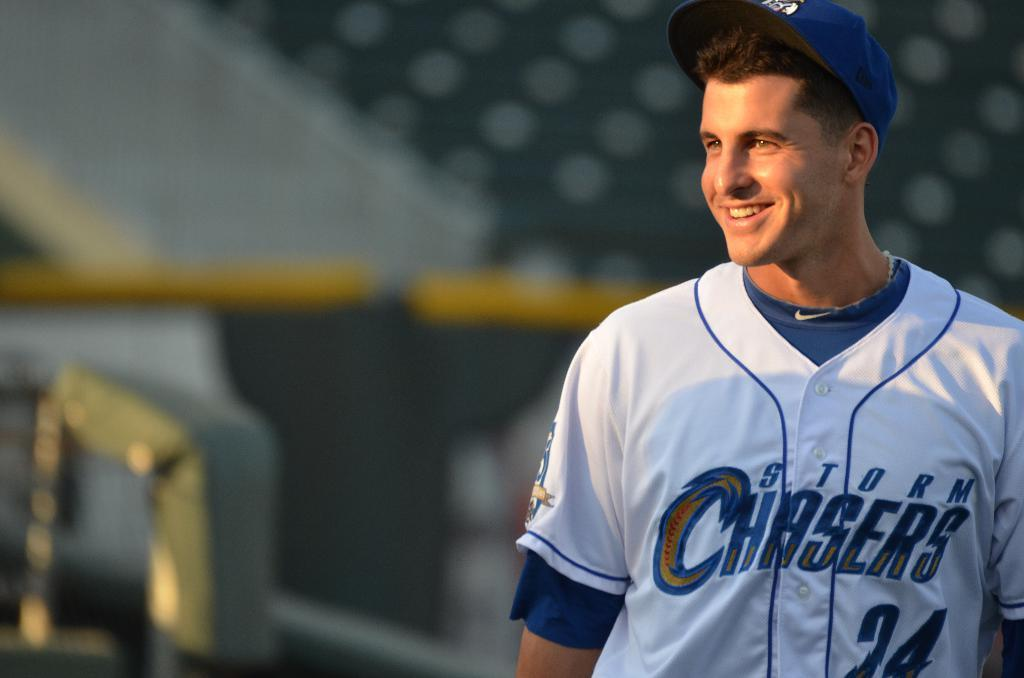What is the main subject of the image? The main subject of the image is a man. What is the man doing in the image? The man is standing in the image. What is the man's facial expression in the image? The man is smiling in the image. Can you describe the background of the image? The background of the image is blurry. What subject is the man teaching in the image? There is no indication in the image that the man is teaching any subject. 